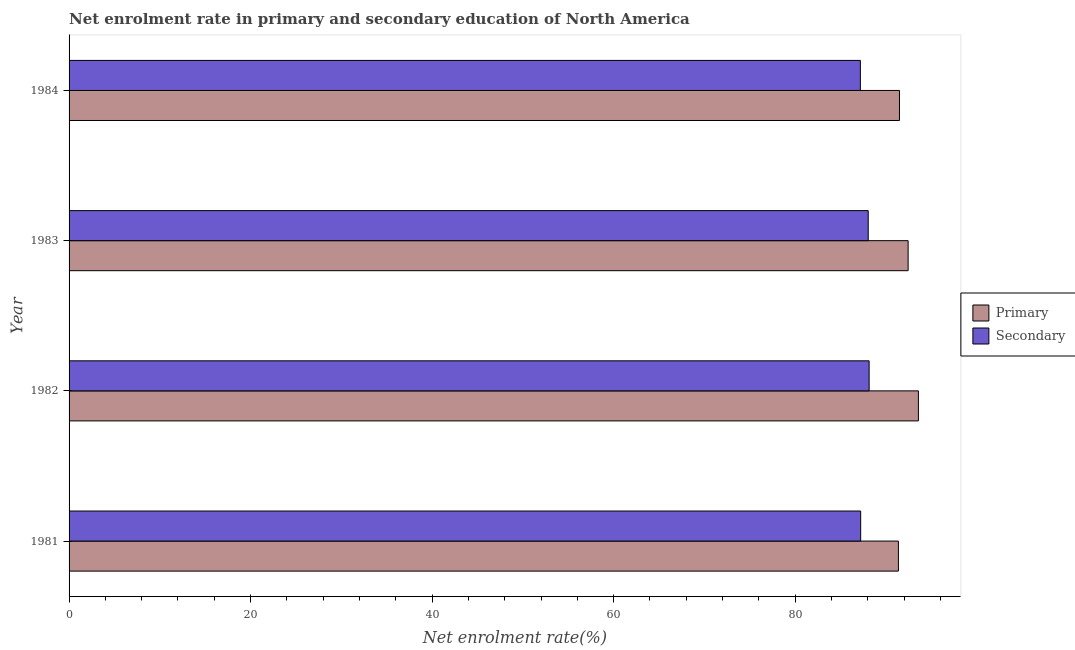How many different coloured bars are there?
Ensure brevity in your answer.  2. How many groups of bars are there?
Provide a succinct answer. 4. How many bars are there on the 1st tick from the top?
Offer a very short reply. 2. In how many cases, is the number of bars for a given year not equal to the number of legend labels?
Your answer should be compact. 0. What is the enrollment rate in primary education in 1983?
Provide a short and direct response. 92.45. Across all years, what is the maximum enrollment rate in secondary education?
Your answer should be very brief. 88.15. Across all years, what is the minimum enrollment rate in primary education?
Your answer should be compact. 91.38. In which year was the enrollment rate in secondary education maximum?
Your answer should be very brief. 1982. In which year was the enrollment rate in secondary education minimum?
Provide a succinct answer. 1984. What is the total enrollment rate in secondary education in the graph?
Offer a very short reply. 350.61. What is the difference between the enrollment rate in primary education in 1981 and that in 1984?
Offer a very short reply. -0.12. What is the difference between the enrollment rate in secondary education in 1984 and the enrollment rate in primary education in 1983?
Make the answer very short. -5.26. What is the average enrollment rate in secondary education per year?
Your response must be concise. 87.65. In the year 1984, what is the difference between the enrollment rate in primary education and enrollment rate in secondary education?
Your answer should be compact. 4.31. In how many years, is the enrollment rate in primary education greater than 88 %?
Ensure brevity in your answer.  4. Is the difference between the enrollment rate in secondary education in 1981 and 1982 greater than the difference between the enrollment rate in primary education in 1981 and 1982?
Offer a very short reply. Yes. What is the difference between the highest and the second highest enrollment rate in primary education?
Offer a very short reply. 1.13. What does the 1st bar from the top in 1982 represents?
Keep it short and to the point. Secondary. What does the 2nd bar from the bottom in 1983 represents?
Provide a succinct answer. Secondary. How many bars are there?
Give a very brief answer. 8. What is the difference between two consecutive major ticks on the X-axis?
Make the answer very short. 20. Does the graph contain any zero values?
Your response must be concise. No. Where does the legend appear in the graph?
Your response must be concise. Center right. What is the title of the graph?
Your response must be concise. Net enrolment rate in primary and secondary education of North America. Does "Male population" appear as one of the legend labels in the graph?
Your response must be concise. No. What is the label or title of the X-axis?
Your answer should be compact. Net enrolment rate(%). What is the Net enrolment rate(%) of Primary in 1981?
Give a very brief answer. 91.38. What is the Net enrolment rate(%) in Secondary in 1981?
Offer a terse response. 87.22. What is the Net enrolment rate(%) of Primary in 1982?
Ensure brevity in your answer.  93.58. What is the Net enrolment rate(%) of Secondary in 1982?
Give a very brief answer. 88.15. What is the Net enrolment rate(%) of Primary in 1983?
Give a very brief answer. 92.45. What is the Net enrolment rate(%) of Secondary in 1983?
Offer a very short reply. 88.05. What is the Net enrolment rate(%) of Primary in 1984?
Offer a terse response. 91.5. What is the Net enrolment rate(%) in Secondary in 1984?
Your answer should be very brief. 87.19. Across all years, what is the maximum Net enrolment rate(%) in Primary?
Keep it short and to the point. 93.58. Across all years, what is the maximum Net enrolment rate(%) in Secondary?
Keep it short and to the point. 88.15. Across all years, what is the minimum Net enrolment rate(%) in Primary?
Ensure brevity in your answer.  91.38. Across all years, what is the minimum Net enrolment rate(%) in Secondary?
Your answer should be compact. 87.19. What is the total Net enrolment rate(%) of Primary in the graph?
Keep it short and to the point. 368.91. What is the total Net enrolment rate(%) of Secondary in the graph?
Your answer should be very brief. 350.61. What is the difference between the Net enrolment rate(%) of Primary in 1981 and that in 1982?
Give a very brief answer. -2.2. What is the difference between the Net enrolment rate(%) of Secondary in 1981 and that in 1982?
Your response must be concise. -0.93. What is the difference between the Net enrolment rate(%) of Primary in 1981 and that in 1983?
Ensure brevity in your answer.  -1.07. What is the difference between the Net enrolment rate(%) of Secondary in 1981 and that in 1983?
Give a very brief answer. -0.83. What is the difference between the Net enrolment rate(%) in Primary in 1981 and that in 1984?
Provide a short and direct response. -0.12. What is the difference between the Net enrolment rate(%) in Secondary in 1981 and that in 1984?
Ensure brevity in your answer.  0.03. What is the difference between the Net enrolment rate(%) in Primary in 1982 and that in 1983?
Your answer should be compact. 1.13. What is the difference between the Net enrolment rate(%) of Secondary in 1982 and that in 1983?
Give a very brief answer. 0.1. What is the difference between the Net enrolment rate(%) in Primary in 1982 and that in 1984?
Ensure brevity in your answer.  2.09. What is the difference between the Net enrolment rate(%) in Secondary in 1982 and that in 1984?
Give a very brief answer. 0.97. What is the difference between the Net enrolment rate(%) in Primary in 1983 and that in 1984?
Make the answer very short. 0.95. What is the difference between the Net enrolment rate(%) in Secondary in 1983 and that in 1984?
Provide a short and direct response. 0.87. What is the difference between the Net enrolment rate(%) in Primary in 1981 and the Net enrolment rate(%) in Secondary in 1982?
Your response must be concise. 3.22. What is the difference between the Net enrolment rate(%) in Primary in 1981 and the Net enrolment rate(%) in Secondary in 1983?
Provide a short and direct response. 3.33. What is the difference between the Net enrolment rate(%) of Primary in 1981 and the Net enrolment rate(%) of Secondary in 1984?
Give a very brief answer. 4.19. What is the difference between the Net enrolment rate(%) in Primary in 1982 and the Net enrolment rate(%) in Secondary in 1983?
Keep it short and to the point. 5.53. What is the difference between the Net enrolment rate(%) of Primary in 1982 and the Net enrolment rate(%) of Secondary in 1984?
Provide a short and direct response. 6.4. What is the difference between the Net enrolment rate(%) in Primary in 1983 and the Net enrolment rate(%) in Secondary in 1984?
Keep it short and to the point. 5.26. What is the average Net enrolment rate(%) in Primary per year?
Ensure brevity in your answer.  92.23. What is the average Net enrolment rate(%) of Secondary per year?
Provide a short and direct response. 87.65. In the year 1981, what is the difference between the Net enrolment rate(%) of Primary and Net enrolment rate(%) of Secondary?
Your answer should be very brief. 4.16. In the year 1982, what is the difference between the Net enrolment rate(%) of Primary and Net enrolment rate(%) of Secondary?
Your answer should be compact. 5.43. In the year 1983, what is the difference between the Net enrolment rate(%) of Primary and Net enrolment rate(%) of Secondary?
Your answer should be very brief. 4.4. In the year 1984, what is the difference between the Net enrolment rate(%) of Primary and Net enrolment rate(%) of Secondary?
Make the answer very short. 4.31. What is the ratio of the Net enrolment rate(%) of Primary in 1981 to that in 1982?
Offer a terse response. 0.98. What is the ratio of the Net enrolment rate(%) of Primary in 1981 to that in 1983?
Your response must be concise. 0.99. What is the ratio of the Net enrolment rate(%) in Secondary in 1981 to that in 1983?
Offer a terse response. 0.99. What is the ratio of the Net enrolment rate(%) in Primary in 1982 to that in 1983?
Offer a very short reply. 1.01. What is the ratio of the Net enrolment rate(%) of Secondary in 1982 to that in 1983?
Your response must be concise. 1. What is the ratio of the Net enrolment rate(%) in Primary in 1982 to that in 1984?
Your response must be concise. 1.02. What is the ratio of the Net enrolment rate(%) of Secondary in 1982 to that in 1984?
Make the answer very short. 1.01. What is the ratio of the Net enrolment rate(%) of Primary in 1983 to that in 1984?
Your answer should be compact. 1.01. What is the ratio of the Net enrolment rate(%) of Secondary in 1983 to that in 1984?
Keep it short and to the point. 1.01. What is the difference between the highest and the second highest Net enrolment rate(%) in Primary?
Your response must be concise. 1.13. What is the difference between the highest and the second highest Net enrolment rate(%) in Secondary?
Keep it short and to the point. 0.1. What is the difference between the highest and the lowest Net enrolment rate(%) of Primary?
Give a very brief answer. 2.2. What is the difference between the highest and the lowest Net enrolment rate(%) in Secondary?
Provide a succinct answer. 0.97. 